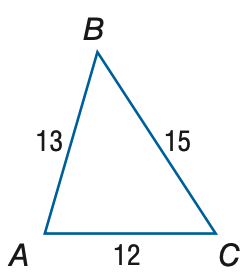Answer the mathemtical geometry problem and directly provide the correct option letter.
Question: Find the measure of \angle C. Round to the nearest degree.
Choices: A: 51 B: 56 C: 61 D: 66 B 